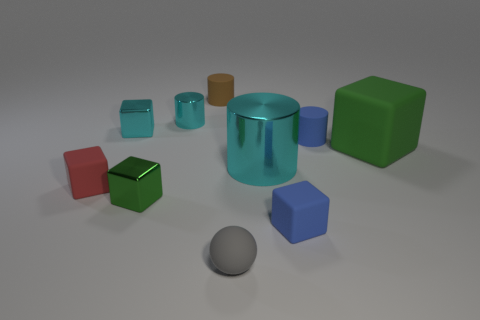Is the size of the blue matte cylinder the same as the green thing that is behind the small red thing?
Make the answer very short. No. What is the material of the small blue thing that is the same shape as the big cyan object?
Ensure brevity in your answer.  Rubber. How many other things are the same size as the green rubber object?
Provide a short and direct response. 1. What is the shape of the blue thing in front of the green block that is in front of the big matte thing that is on the right side of the small matte sphere?
Offer a very short reply. Cube. There is a thing that is on the right side of the tiny blue rubber cube and to the left of the green rubber object; what is its shape?
Offer a very short reply. Cylinder. What number of things are either large red metallic cubes or small blocks that are on the left side of the tiny gray rubber sphere?
Keep it short and to the point. 3. Are the small brown thing and the large cyan thing made of the same material?
Your response must be concise. No. How many other objects are there of the same shape as the small brown thing?
Give a very brief answer. 3. What size is the cylinder that is both behind the small blue cylinder and in front of the small brown cylinder?
Give a very brief answer. Small. What number of metallic things are either cylinders or tiny green cubes?
Your answer should be compact. 3. 